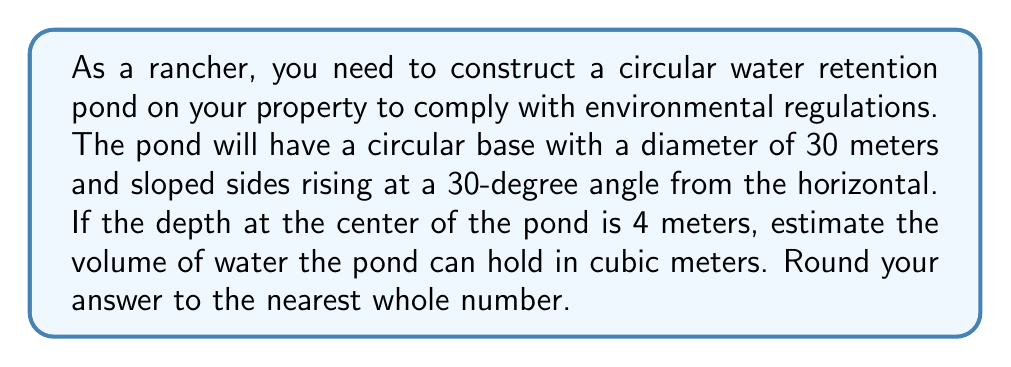Give your solution to this math problem. Let's approach this step-by-step:

1) First, we need to calculate the radius of the base:
   $r = 30 \text{ m} \div 2 = 15 \text{ m}$

2) The pond forms a truncated cone. We need to find the radius of the top surface:
   The horizontal distance the side travels is: $4 \text{ m} \div \tan(30°)$
   $\tan(30°) = \frac{1}{\sqrt{3}} \approx 0.577$
   Horizontal distance $= 4 \text{ m} \div 0.577 \approx 6.93 \text{ m}$

3) So the radius of the top surface is:
   $R = 15 \text{ m} + 6.93 \text{ m} = 21.93 \text{ m}$

4) The volume of a truncated cone is given by the formula:
   $$V = \frac{1}{3}\pi h(R^2 + r^2 + Rr)$$
   Where $h$ is the height, $R$ is the radius of the top surface, and $r$ is the radius of the base.

5) Substituting our values:
   $$V = \frac{1}{3}\pi \cdot 4(21.93^2 + 15^2 + 21.93 \cdot 15)$$

6) Calculating:
   $$V = \frac{1}{3}\pi \cdot 4(480.92 + 225 + 328.95)$$
   $$V = \frac{4\pi}{3}(1034.87)$$
   $$V \approx 4334.96 \text{ m}^3$$

7) Rounding to the nearest whole number:
   $V \approx 4335 \text{ m}^3$

[asy]
import geometry;

size(200);

pair O = (0,0);
real r = 3;
real R = 4.386;
real h = 0.8;

path base = circle(O, r);
path top = circle((0,h), R);

draw(base);
draw(top);
draw((r,0)--(R,h));
draw((-r,0)--(-R,h));
draw((0,0)--(0,h));

label("r", (r/2,0), S);
label("R", (R/2,h), N);
label("h", (0,h/2), E);

[/asy]
Answer: 4335 m³ 